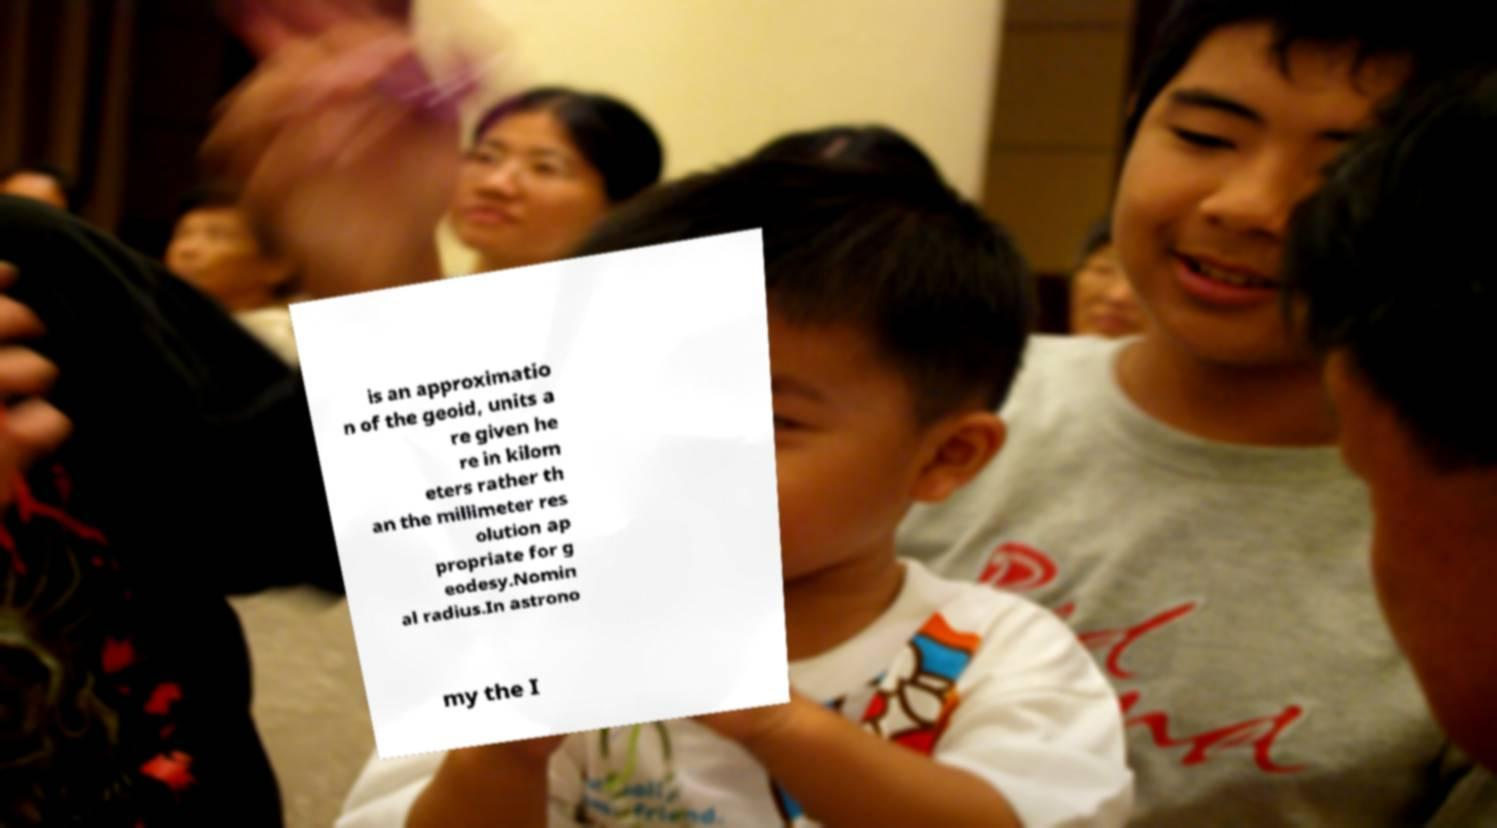Can you accurately transcribe the text from the provided image for me? is an approximatio n of the geoid, units a re given he re in kilom eters rather th an the millimeter res olution ap propriate for g eodesy.Nomin al radius.In astrono my the I 